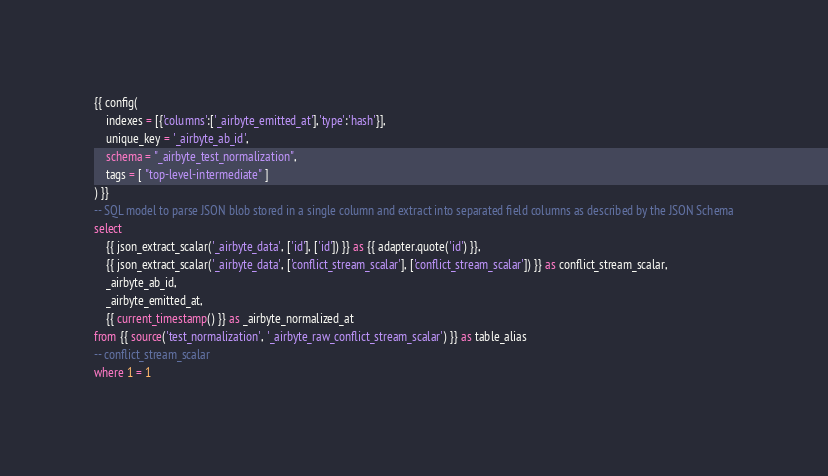<code> <loc_0><loc_0><loc_500><loc_500><_SQL_>{{ config(
    indexes = [{'columns':['_airbyte_emitted_at'],'type':'hash'}],
    unique_key = '_airbyte_ab_id',
    schema = "_airbyte_test_normalization",
    tags = [ "top-level-intermediate" ]
) }}
-- SQL model to parse JSON blob stored in a single column and extract into separated field columns as described by the JSON Schema
select
    {{ json_extract_scalar('_airbyte_data', ['id'], ['id']) }} as {{ adapter.quote('id') }},
    {{ json_extract_scalar('_airbyte_data', ['conflict_stream_scalar'], ['conflict_stream_scalar']) }} as conflict_stream_scalar,
    _airbyte_ab_id,
    _airbyte_emitted_at,
    {{ current_timestamp() }} as _airbyte_normalized_at
from {{ source('test_normalization', '_airbyte_raw_conflict_stream_scalar') }} as table_alias
-- conflict_stream_scalar
where 1 = 1

</code> 